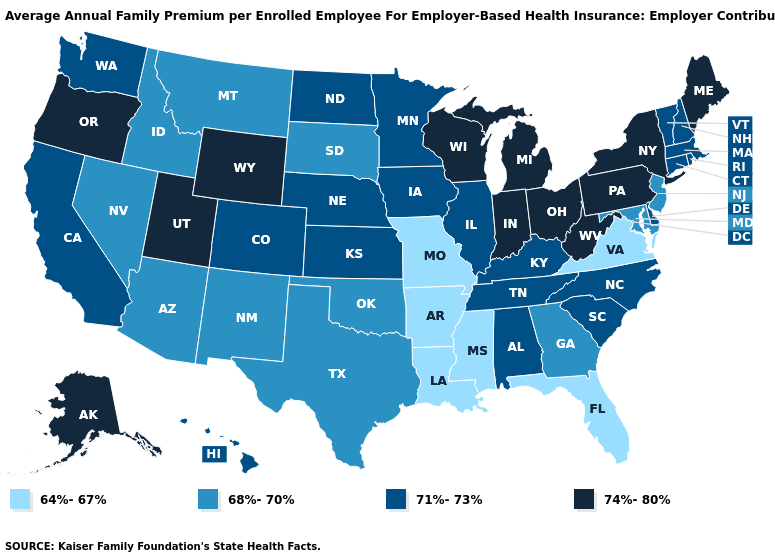Which states have the lowest value in the South?
Quick response, please. Arkansas, Florida, Louisiana, Mississippi, Virginia. What is the highest value in the South ?
Quick response, please. 74%-80%. Does Mississippi have the lowest value in the South?
Be succinct. Yes. What is the value of Arkansas?
Write a very short answer. 64%-67%. Which states have the lowest value in the USA?
Answer briefly. Arkansas, Florida, Louisiana, Mississippi, Missouri, Virginia. Does the first symbol in the legend represent the smallest category?
Concise answer only. Yes. Name the states that have a value in the range 71%-73%?
Give a very brief answer. Alabama, California, Colorado, Connecticut, Delaware, Hawaii, Illinois, Iowa, Kansas, Kentucky, Massachusetts, Minnesota, Nebraska, New Hampshire, North Carolina, North Dakota, Rhode Island, South Carolina, Tennessee, Vermont, Washington. What is the value of Rhode Island?
Quick response, please. 71%-73%. Among the states that border Virginia , does West Virginia have the highest value?
Short answer required. Yes. What is the value of Nebraska?
Keep it brief. 71%-73%. Name the states that have a value in the range 74%-80%?
Keep it brief. Alaska, Indiana, Maine, Michigan, New York, Ohio, Oregon, Pennsylvania, Utah, West Virginia, Wisconsin, Wyoming. What is the highest value in states that border Maryland?
Give a very brief answer. 74%-80%. What is the value of Rhode Island?
Write a very short answer. 71%-73%. What is the value of Montana?
Answer briefly. 68%-70%. What is the lowest value in states that border Tennessee?
Quick response, please. 64%-67%. 